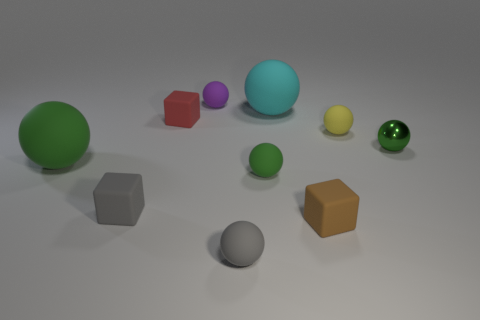Subtract all red cubes. How many cubes are left? 2 Subtract all purple balls. How many balls are left? 6 Subtract all balls. How many objects are left? 3 Subtract 2 spheres. How many spheres are left? 5 Subtract all red cubes. How many green spheres are left? 3 Add 5 red things. How many red things are left? 6 Add 8 yellow spheres. How many yellow spheres exist? 9 Subtract 1 brown blocks. How many objects are left? 9 Subtract all red blocks. Subtract all blue cylinders. How many blocks are left? 2 Subtract all matte blocks. Subtract all tiny green balls. How many objects are left? 5 